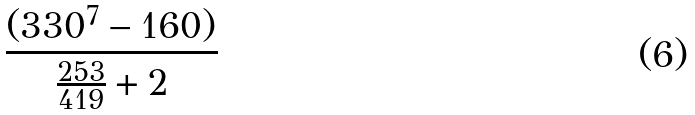Convert formula to latex. <formula><loc_0><loc_0><loc_500><loc_500>\frac { ( 3 3 0 ^ { 7 } - 1 6 0 ) } { \frac { 2 5 3 } { 4 1 9 } + 2 }</formula> 